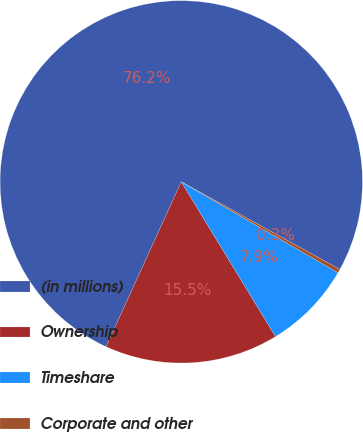<chart> <loc_0><loc_0><loc_500><loc_500><pie_chart><fcel>(in millions)<fcel>Ownership<fcel>Timeshare<fcel>Corporate and other<nl><fcel>76.22%<fcel>15.52%<fcel>7.93%<fcel>0.34%<nl></chart> 